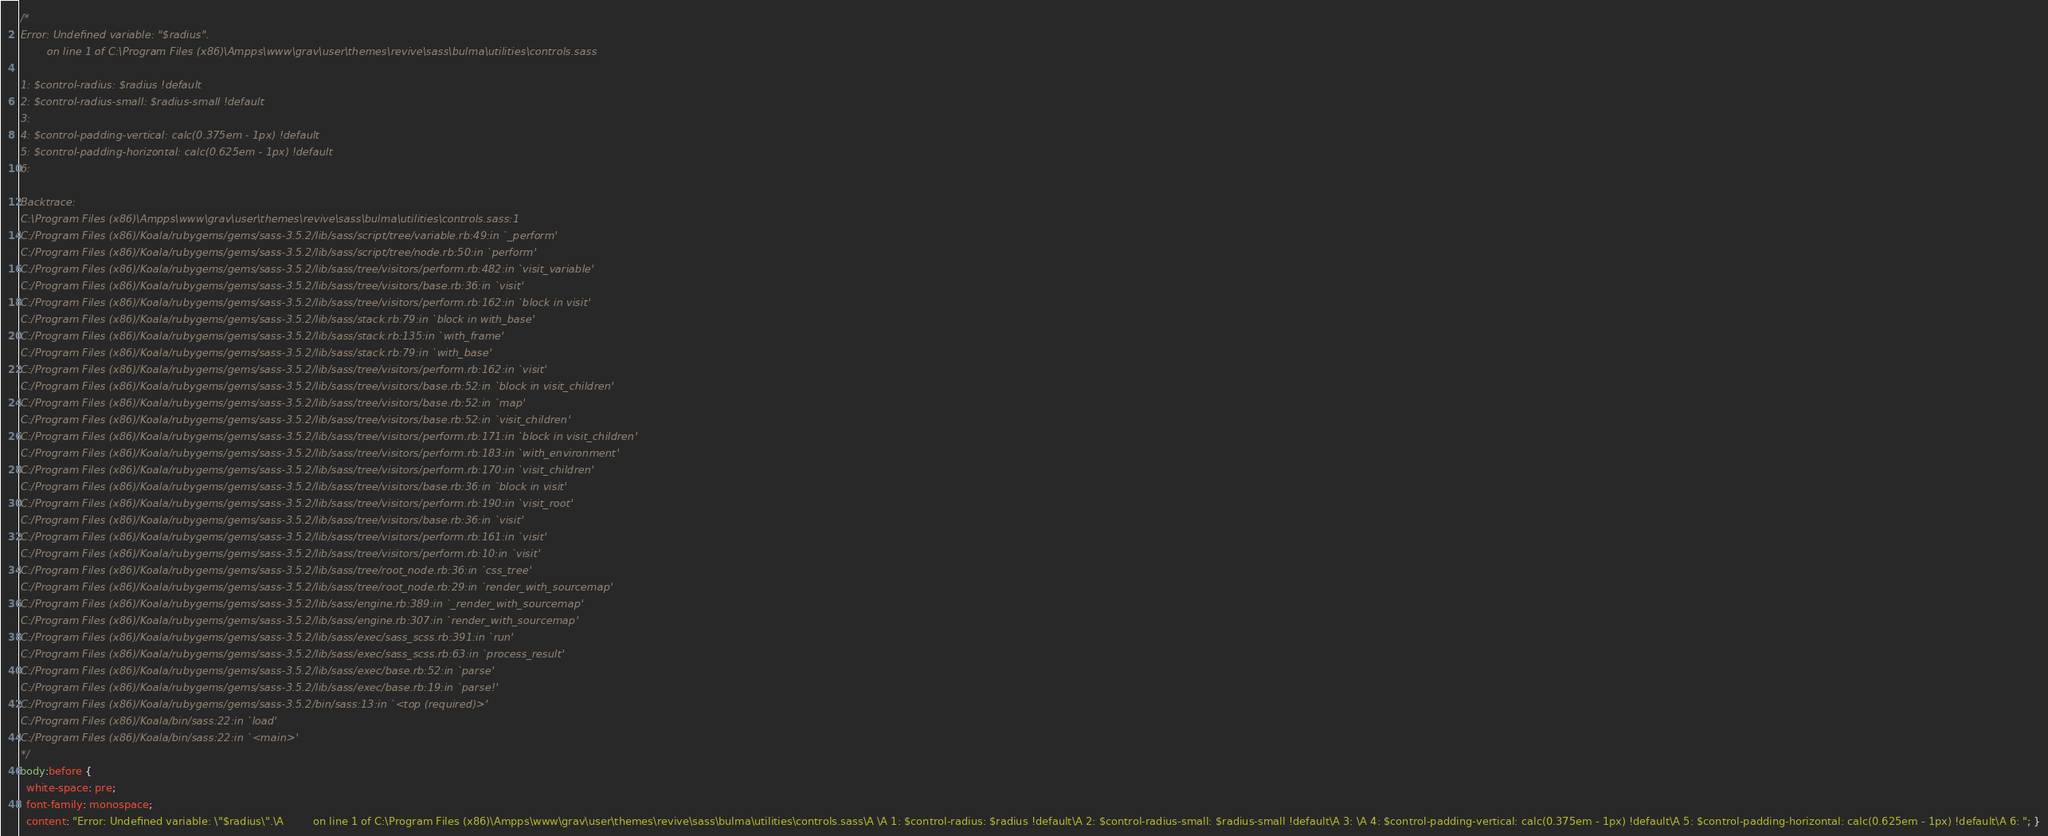Convert code to text. <code><loc_0><loc_0><loc_500><loc_500><_CSS_>/*
Error: Undefined variable: "$radius".
        on line 1 of C:\Program Files (x86)\Ampps\www\grav\user\themes\revive\sass\bulma\utilities\controls.sass

1: $control-radius: $radius !default
2: $control-radius-small: $radius-small !default
3: 
4: $control-padding-vertical: calc(0.375em - 1px) !default
5: $control-padding-horizontal: calc(0.625em - 1px) !default
6: 

Backtrace:
C:\Program Files (x86)\Ampps\www\grav\user\themes\revive\sass\bulma\utilities\controls.sass:1
C:/Program Files (x86)/Koala/rubygems/gems/sass-3.5.2/lib/sass/script/tree/variable.rb:49:in `_perform'
C:/Program Files (x86)/Koala/rubygems/gems/sass-3.5.2/lib/sass/script/tree/node.rb:50:in `perform'
C:/Program Files (x86)/Koala/rubygems/gems/sass-3.5.2/lib/sass/tree/visitors/perform.rb:482:in `visit_variable'
C:/Program Files (x86)/Koala/rubygems/gems/sass-3.5.2/lib/sass/tree/visitors/base.rb:36:in `visit'
C:/Program Files (x86)/Koala/rubygems/gems/sass-3.5.2/lib/sass/tree/visitors/perform.rb:162:in `block in visit'
C:/Program Files (x86)/Koala/rubygems/gems/sass-3.5.2/lib/sass/stack.rb:79:in `block in with_base'
C:/Program Files (x86)/Koala/rubygems/gems/sass-3.5.2/lib/sass/stack.rb:135:in `with_frame'
C:/Program Files (x86)/Koala/rubygems/gems/sass-3.5.2/lib/sass/stack.rb:79:in `with_base'
C:/Program Files (x86)/Koala/rubygems/gems/sass-3.5.2/lib/sass/tree/visitors/perform.rb:162:in `visit'
C:/Program Files (x86)/Koala/rubygems/gems/sass-3.5.2/lib/sass/tree/visitors/base.rb:52:in `block in visit_children'
C:/Program Files (x86)/Koala/rubygems/gems/sass-3.5.2/lib/sass/tree/visitors/base.rb:52:in `map'
C:/Program Files (x86)/Koala/rubygems/gems/sass-3.5.2/lib/sass/tree/visitors/base.rb:52:in `visit_children'
C:/Program Files (x86)/Koala/rubygems/gems/sass-3.5.2/lib/sass/tree/visitors/perform.rb:171:in `block in visit_children'
C:/Program Files (x86)/Koala/rubygems/gems/sass-3.5.2/lib/sass/tree/visitors/perform.rb:183:in `with_environment'
C:/Program Files (x86)/Koala/rubygems/gems/sass-3.5.2/lib/sass/tree/visitors/perform.rb:170:in `visit_children'
C:/Program Files (x86)/Koala/rubygems/gems/sass-3.5.2/lib/sass/tree/visitors/base.rb:36:in `block in visit'
C:/Program Files (x86)/Koala/rubygems/gems/sass-3.5.2/lib/sass/tree/visitors/perform.rb:190:in `visit_root'
C:/Program Files (x86)/Koala/rubygems/gems/sass-3.5.2/lib/sass/tree/visitors/base.rb:36:in `visit'
C:/Program Files (x86)/Koala/rubygems/gems/sass-3.5.2/lib/sass/tree/visitors/perform.rb:161:in `visit'
C:/Program Files (x86)/Koala/rubygems/gems/sass-3.5.2/lib/sass/tree/visitors/perform.rb:10:in `visit'
C:/Program Files (x86)/Koala/rubygems/gems/sass-3.5.2/lib/sass/tree/root_node.rb:36:in `css_tree'
C:/Program Files (x86)/Koala/rubygems/gems/sass-3.5.2/lib/sass/tree/root_node.rb:29:in `render_with_sourcemap'
C:/Program Files (x86)/Koala/rubygems/gems/sass-3.5.2/lib/sass/engine.rb:389:in `_render_with_sourcemap'
C:/Program Files (x86)/Koala/rubygems/gems/sass-3.5.2/lib/sass/engine.rb:307:in `render_with_sourcemap'
C:/Program Files (x86)/Koala/rubygems/gems/sass-3.5.2/lib/sass/exec/sass_scss.rb:391:in `run'
C:/Program Files (x86)/Koala/rubygems/gems/sass-3.5.2/lib/sass/exec/sass_scss.rb:63:in `process_result'
C:/Program Files (x86)/Koala/rubygems/gems/sass-3.5.2/lib/sass/exec/base.rb:52:in `parse'
C:/Program Files (x86)/Koala/rubygems/gems/sass-3.5.2/lib/sass/exec/base.rb:19:in `parse!'
C:/Program Files (x86)/Koala/rubygems/gems/sass-3.5.2/bin/sass:13:in `<top (required)>'
C:/Program Files (x86)/Koala/bin/sass:22:in `load'
C:/Program Files (x86)/Koala/bin/sass:22:in `<main>'
*/
body:before {
  white-space: pre;
  font-family: monospace;
  content: "Error: Undefined variable: \"$radius\".\A         on line 1 of C:\Program Files (x86)\Ampps\www\grav\user\themes\revive\sass\bulma\utilities\controls.sass\A \A 1: $control-radius: $radius !default\A 2: $control-radius-small: $radius-small !default\A 3: \A 4: $control-padding-vertical: calc(0.375em - 1px) !default\A 5: $control-padding-horizontal: calc(0.625em - 1px) !default\A 6: "; }
</code> 